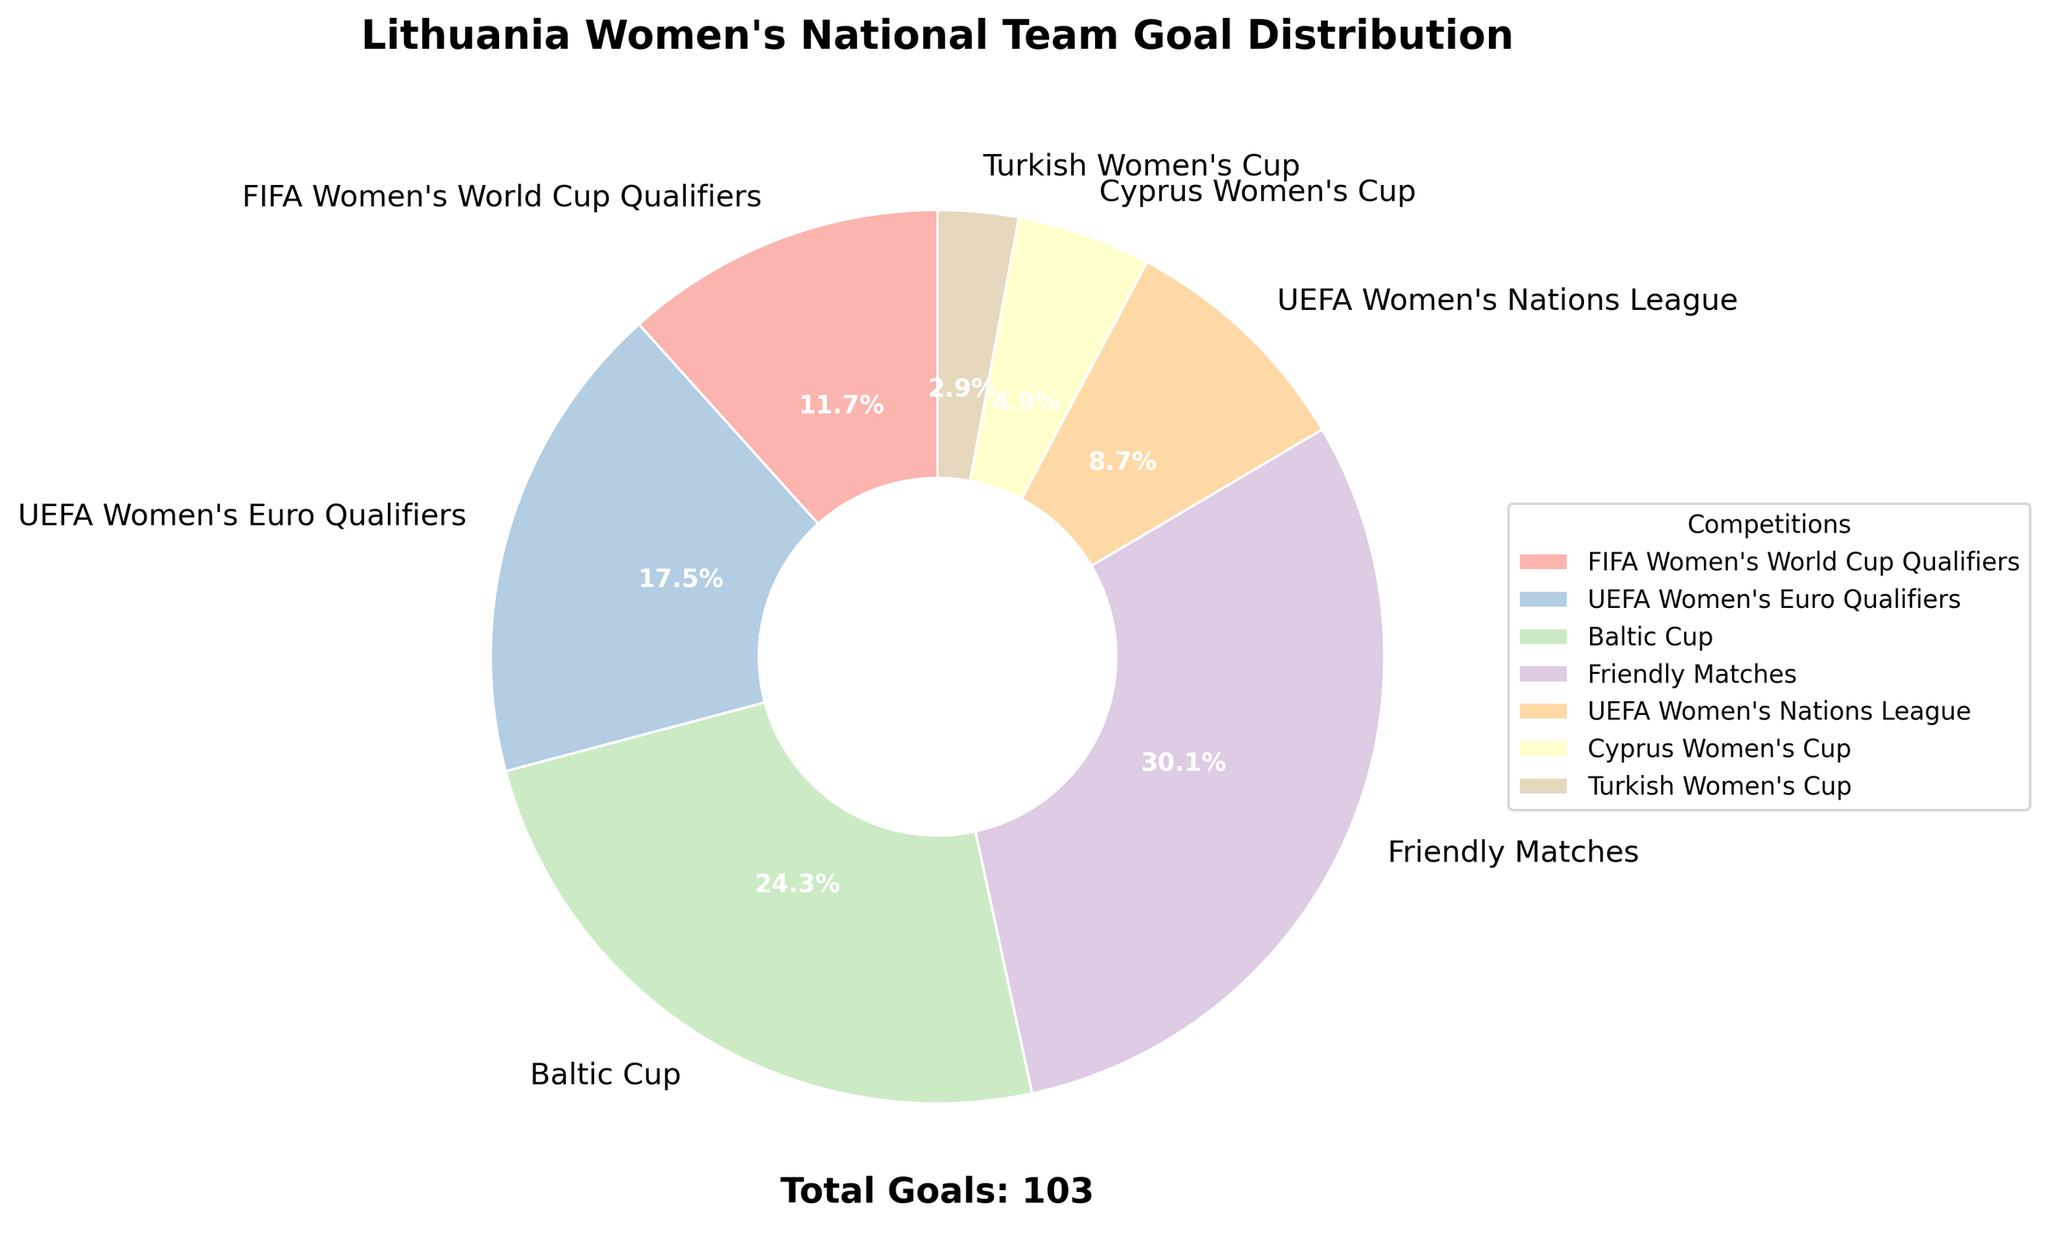How many total goals were scored by Lithuania's women's national team according to the pie chart? The number at the bottom of the chart shows the total goals.
Answer: 103 Which competition has the highest percentage of goals scored? The pie chart with the largest section is labeled "Friendly Matches".
Answer: Friendly Matches Which competition has the lowest number of goals scored? The smallest slice on the pie chart is labeled "Turkish Women's Cup".
Answer: Turkish Women's Cup By how much do the goals in the UEFA Women's Euro Qualifiers differ from those in the Baltic Cup? The number of goals in the UEFA Women's Euro Qualifiers is 18, and the Baltic Cup is 25. The difference is 25 - 18.
Answer: 7 What is the combined goal percentage of the Cyprus Women's Cup and the Turkish Women's Cup? The chart shows 5 goals for the Cyprus Women's Cup and 3 for the Turkish Women's Cup. Their combined percentage is the sum of their individual percentages.
Answer: 7.8% If the Baltic Cup and UEFA Women's Nations League goals were combined into a single category, what percentage of the total goals would this new category represent? The Baltic Cup has 25 goals, and the UEFA Women's Nations League has 9. Combined, they have 25 + 9 = 34 goals. The total number of goals is 103, so the percentage is (34/103) * 100%.
Answer: 33.0% How many more goals were scored in FIFA Women's World Cup Qualifiers compared to the Turkish Women's Cup? There are 12 goals in the FIFA Women's World Cup Qualifiers and 3 goals in the Turkish Women's Cup. The difference is 12 - 3.
Answer: 9 Does the color of the wedge representing the Baltic Cup match the background color of any other wedge? Visual inspection of the chart shows that the color of the Baltic Cup wedge is unique compared to other wedges.
Answer: No 